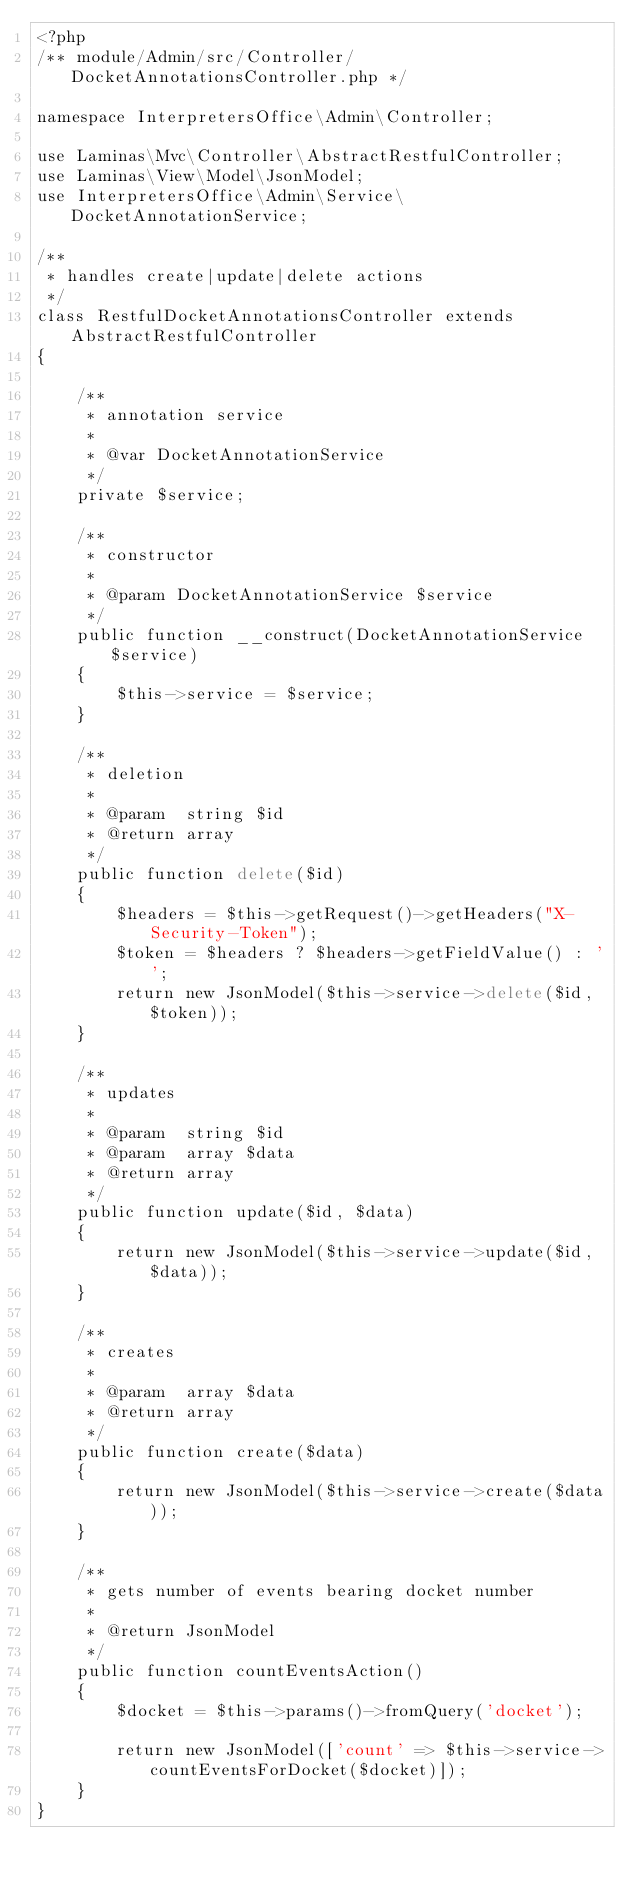<code> <loc_0><loc_0><loc_500><loc_500><_PHP_><?php
/** module/Admin/src/Controller/DocketAnnotationsController.php */

namespace InterpretersOffice\Admin\Controller;

use Laminas\Mvc\Controller\AbstractRestfulController;
use Laminas\View\Model\JsonModel;
use InterpretersOffice\Admin\Service\DocketAnnotationService;

/**
 * handles create|update|delete actions
 */
class RestfulDocketAnnotationsController extends AbstractRestfulController
{

    /**
     * annotation service
     *
     * @var DocketAnnotationService
     */
    private $service;

    /**
     * constructor
     *
     * @param DocketAnnotationService $service
     */
    public function __construct(DocketAnnotationService $service)
    {
        $this->service = $service;
    }

    /**
     * deletion
     *
     * @param  string $id
     * @return array
     */
    public function delete($id)
    {
        $headers = $this->getRequest()->getHeaders("X-Security-Token");
        $token = $headers ? $headers->getFieldValue() : '';
        return new JsonModel($this->service->delete($id, $token));
    }

    /**
     * updates
     *
     * @param  string $id
     * @param  array $data
     * @return array
     */
    public function update($id, $data)
    {
        return new JsonModel($this->service->update($id, $data));
    }

    /**
     * creates
     *
     * @param  array $data
     * @return array
     */
    public function create($data)
    {
        return new JsonModel($this->service->create($data));
    }

    /**
     * gets number of events bearing docket number
     *
     * @return JsonModel
     */
    public function countEventsAction()
    {
        $docket = $this->params()->fromQuery('docket');

        return new JsonModel(['count' => $this->service->countEventsForDocket($docket)]);
    }
}
</code> 